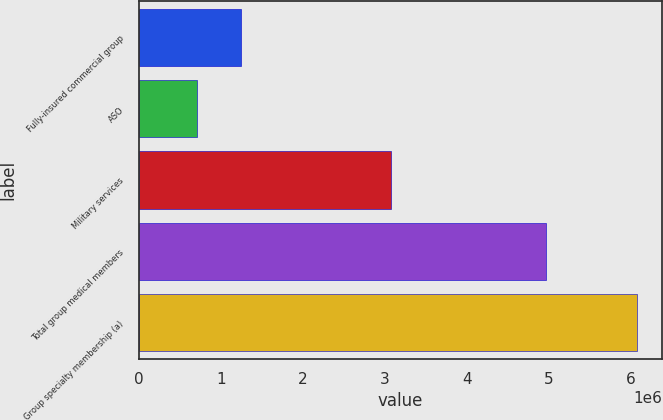Convert chart to OTSL. <chart><loc_0><loc_0><loc_500><loc_500><bar_chart><fcel>Fully-insured commercial group<fcel>ASO<fcel>Military services<fcel>Total group medical members<fcel>Group specialty membership (a)<nl><fcel>1.2465e+06<fcel>710700<fcel>3.0744e+06<fcel>4.9634e+06<fcel>6.0687e+06<nl></chart> 